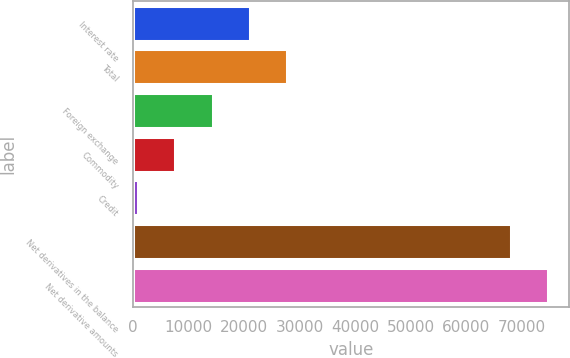Convert chart. <chart><loc_0><loc_0><loc_500><loc_500><bar_chart><fcel>Interest rate<fcel>Total<fcel>Foreign exchange<fcel>Commodity<fcel>Credit<fcel>Net derivatives in the balance<fcel>Net derivative amounts<nl><fcel>21060.1<fcel>27776.8<fcel>14343.4<fcel>7626.7<fcel>910<fcel>68077<fcel>74793.7<nl></chart> 